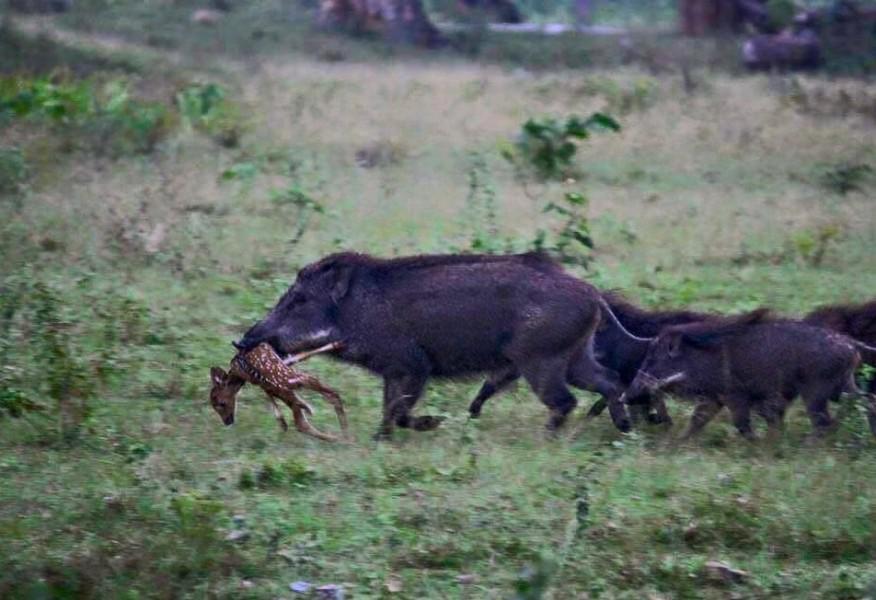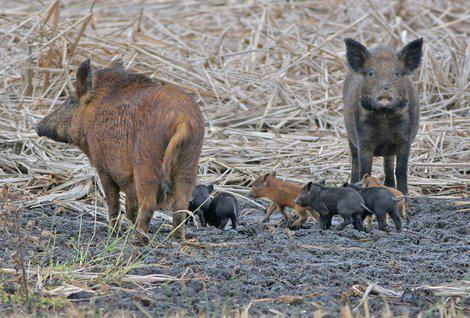The first image is the image on the left, the second image is the image on the right. For the images shown, is this caption "Every picture has more than 6 pigs" true? Answer yes or no. No. The first image is the image on the left, the second image is the image on the right. Evaluate the accuracy of this statement regarding the images: "There are many wild boar hanging together in a pack near the woods". Is it true? Answer yes or no. No. 